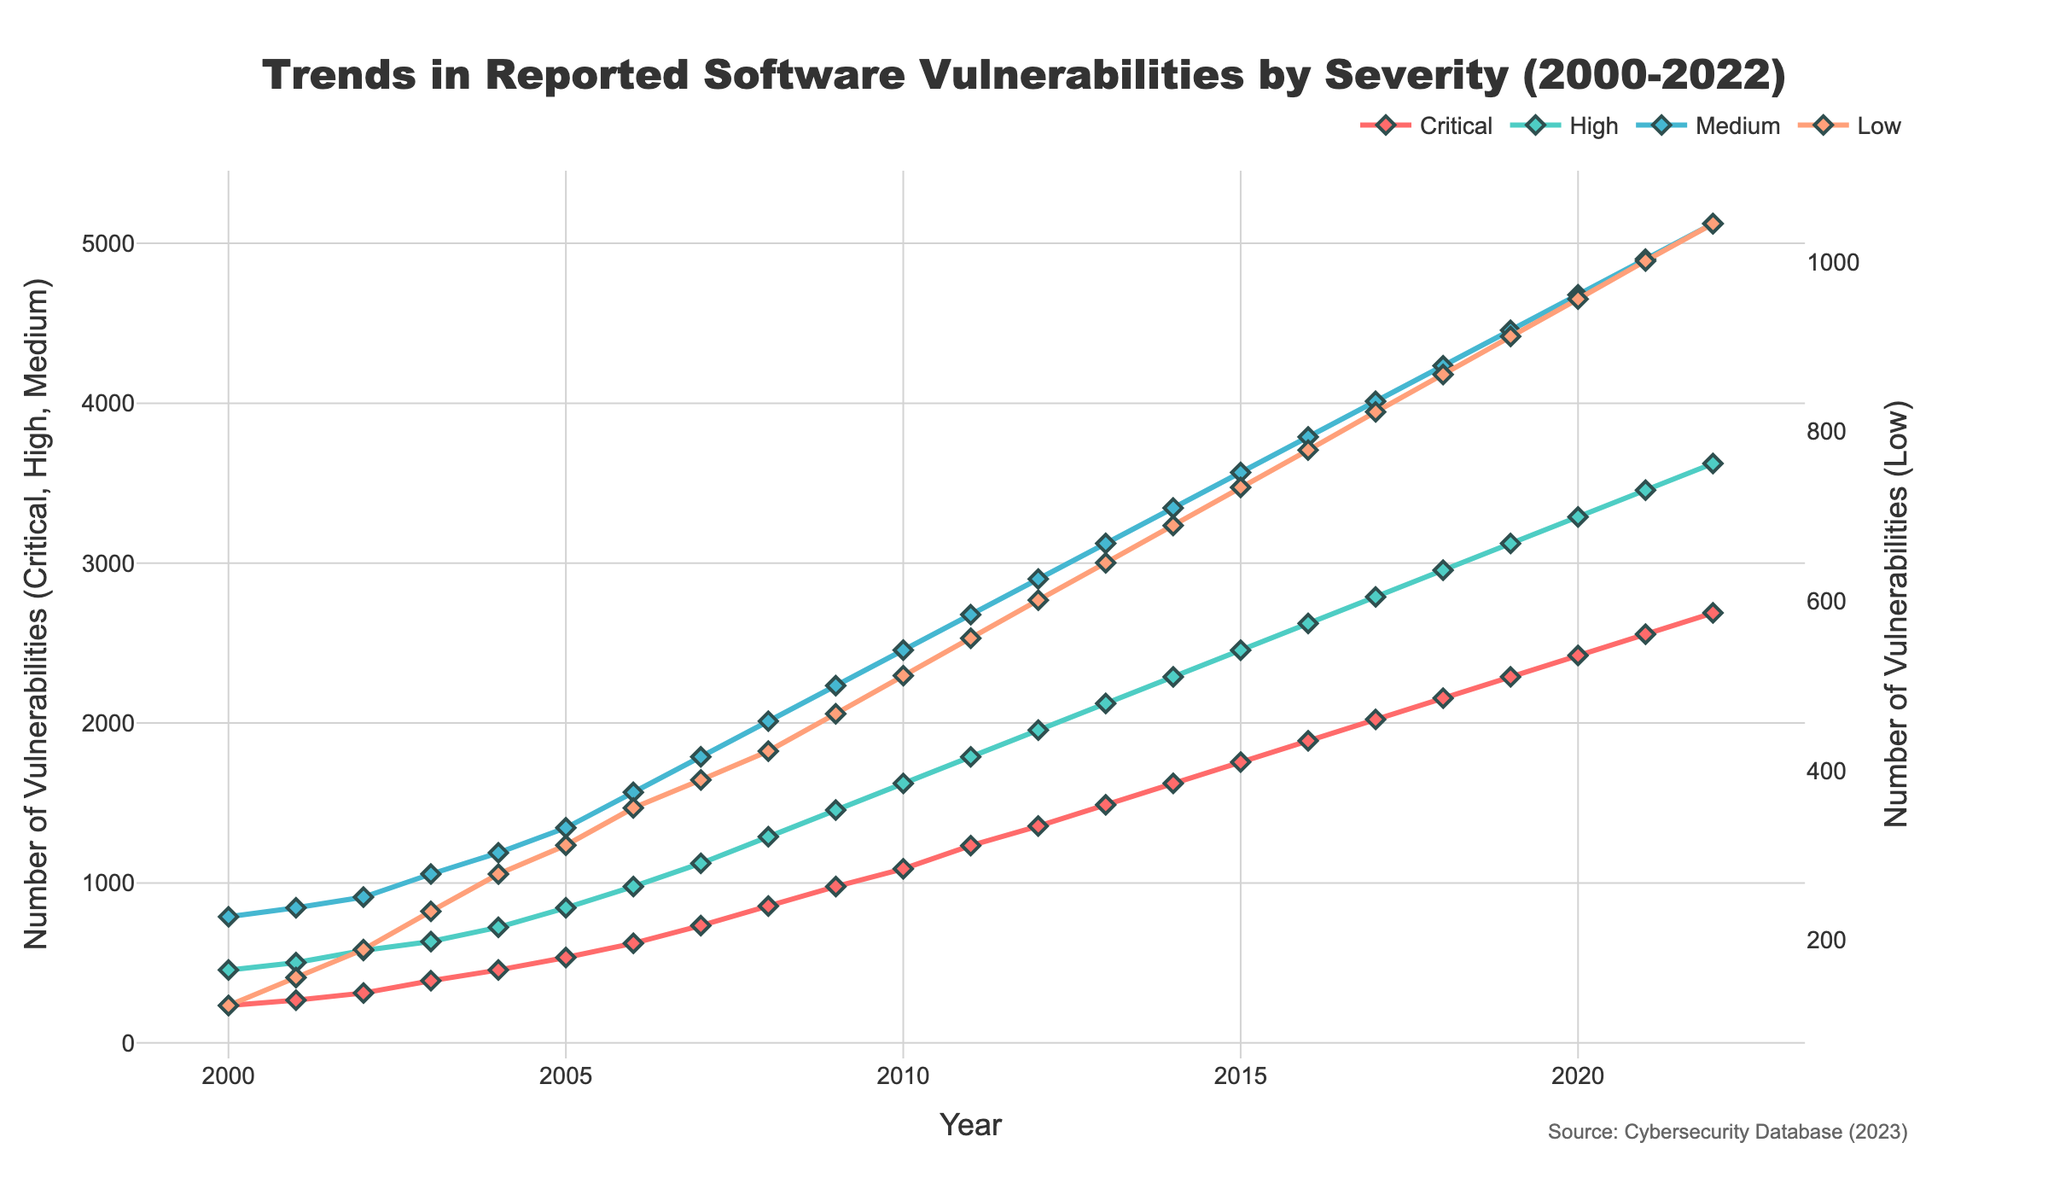What is the highest number of Critical vulnerabilities reported in a single year? Look for the peak of the 'Critical' line in the figure to identify the highest point. The highest number is 2689 in 2022.
Answer: 2689 In what year did Medium level vulnerabilities surpass 3000 for the first time? Find the point on the 'Medium' line where it first crosses 3000. This happens in 2011, where it reaches 3123.
Answer: 2013 How many more High severity vulnerabilities were reported in 2018 compared to 2000? Subtract the number of High vulnerabilities in 2000 from the number in 2018. In 2018, there were 2956 High vulnerabilities, and in 2000, there were 456. The difference is 2956 - 456 = 2500.
Answer: 2500 Which year saw the largest increase in Low vulnerabilities compared to the previous year? Calculate the year-over-year differences for the 'Low' line and identify the largest increase. The largest increase is between 2011 (556) and 2012 (601), a difference of 45.
Answer: 2011-2012 Are there any years where the number of Critical and High vulnerabilities is equal? Check if there are any years where the points for 'Critical' and 'High' lines coincide. No such year exists.
Answer: No What is the average number of Medium severity vulnerabilities reported between 2000 and 2010? Sum the number of Medium vulnerabilities from 2000 to 2010 and divide by the number of years (11). (789+845+912+1056+1189+1345+1567+1789+2012+2234+2456)/11 = 1659.27
Answer: 1659.27 Which severity level has shown the most consistent increase over the years? Observe all four lines to identify which has the steadiest upward slope without significant fluctuations. The 'Medium' line has the most consistent increase.
Answer: Medium What is the visual difference between the lines for Medium and Low vulnerabilities? Compare the 'Medium' and 'Low' lines in terms of color and position. 'Medium' is represented by a blue line, higher on the chart, while 'Low' is represented by an orange line, lower on the chart.
Answer: Medium is blue and higher; Low is orange and lower In what year did the number of Low severity vulnerabilities first cross 500? Identify the first point where the 'Low' line crosses the 500 mark. This happens in 2010.
Answer: 2010 Is the trend for Critical vulnerabilities more or less steep than that for High vulnerabilities? Compare the slopes of 'Critical' and 'High' lines. The 'Critical' line has a steeper upward trend than the 'High' line.
Answer: More steep 